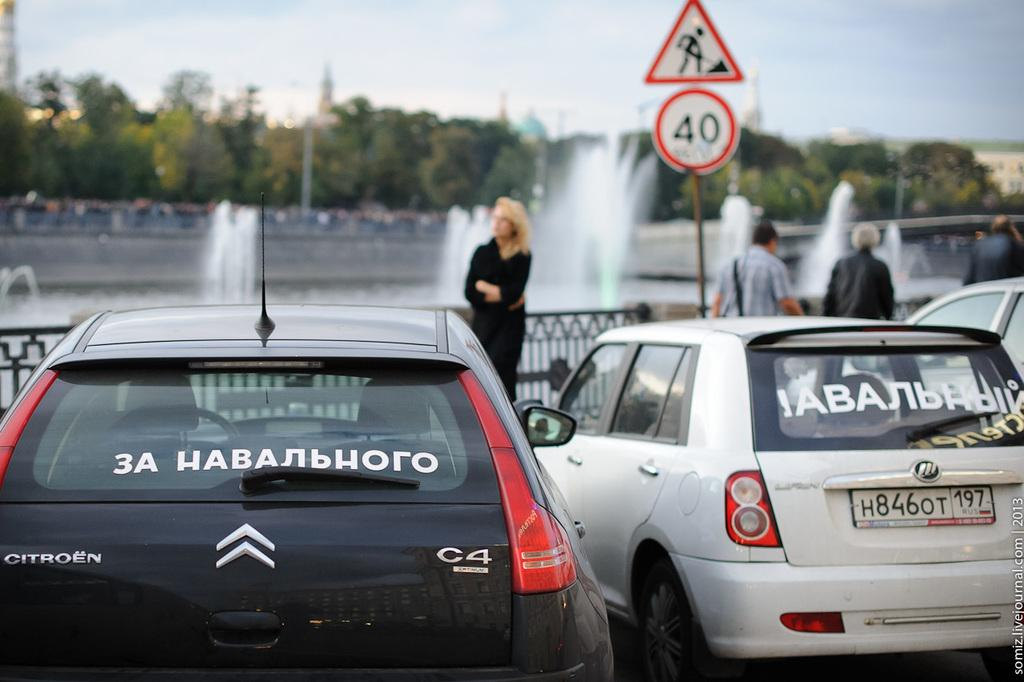What types of objects can be seen in the image? There are vehicles, fencing, fountains, poles, signboards, and trees in the image. Are there any structures or features that are not part of the natural environment? Yes, there are fencing, poles, signboards, and vehicles in the image. Can you describe the people in the image? There are people present in the image, but their specific actions or characteristics are not mentioned in the provided facts. What is the color of the sky in the image? The sky is blue and white in color. What type of sand can be seen on the beach in the image? There is no beach or sand present in the image. What flag is being raised by the people in the image? There are no flags or people raising flags in the image. 